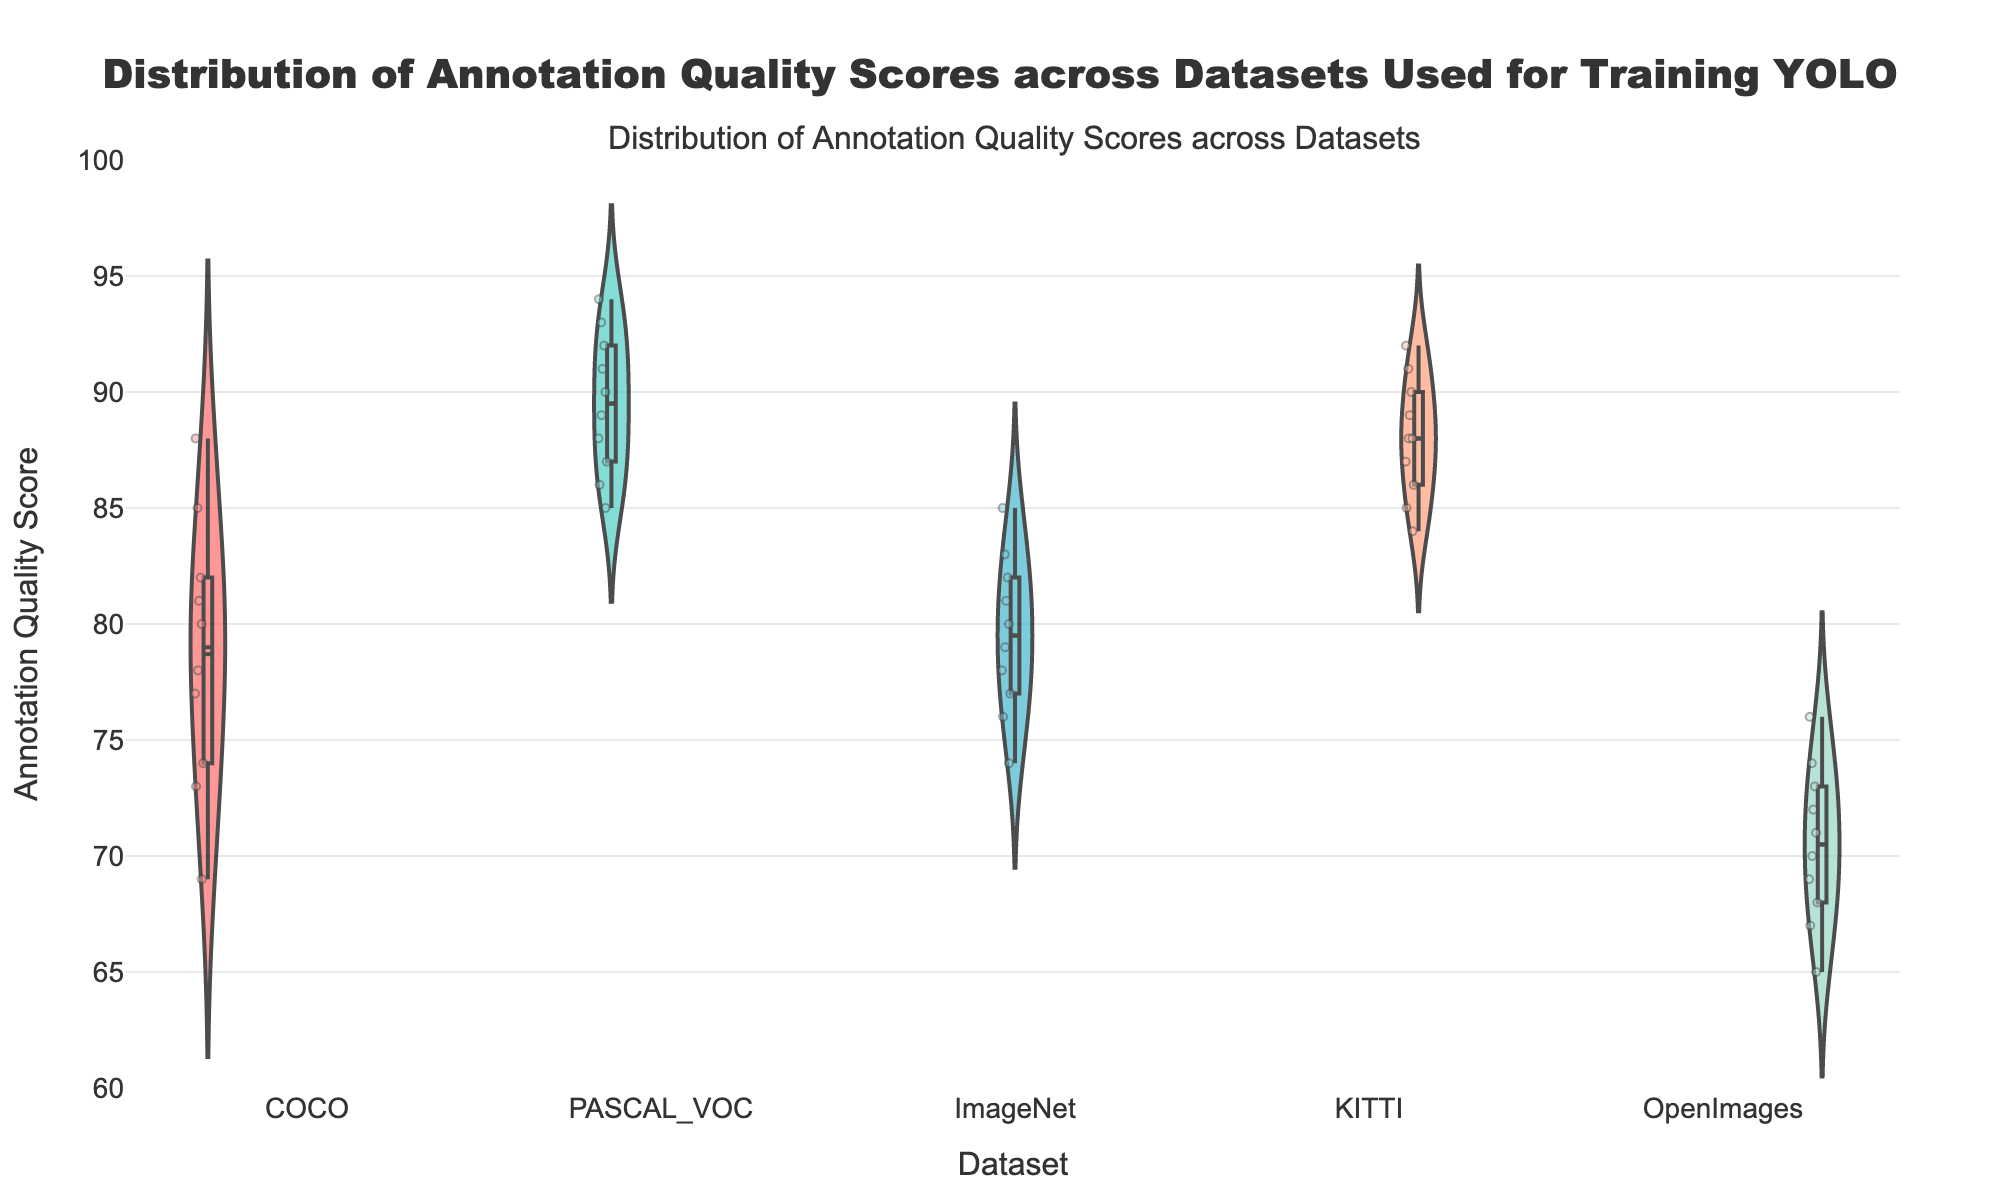What's the title of the subplot? The title of the subplot is mentioned at the top of the figure.
Answer: Distribution of Annotation Quality Scores across Datasets Which dataset has the highest median annotation quality score? The dataset with the highest median score can be identified by looking at the meanline across the violin plots. The dataset with the highest meanline is PASCAL_VOC.
Answer: PASCAL_VOC What is the range of annotation quality scores for the COCO dataset? The range can be determined by looking at the upper and lower extremes of the COCO violin plot. COCO ranges from approximately 69 to 88.
Answer: 69-88 How does the median quality score of KITTI compare to that of ImageNet? Compare the median (indicated by the meanline) of both datasets. KITTI's median is slightly higher than ImageNet's.
Answer: KITTI's median is higher What is the interquartile range (IQR) of the annotation quality scores for OpenImages? To find the IQR, look for the box within the violin plot for OpenImages. The boundaries of this box represent the first and third quartiles. OpenImages IQR is from approximately 68 to 73.
Answer: 68-73 Which dataset shows the widest distribution of annotation quality scores? This can be determined by comparing the width of the violin plots. OpenImages shows the widest distribution.
Answer: OpenImages Which dataset has the least variability in annotation quality scores? The dataset with the narrowest violin plot width shows the least variability. PASCAL_VOC shows the least variability.
Answer: PASCAL_VOC Which dataset has scores below 70? By examining the plots, OpenImages has scores that go below 70.
Answer: OpenImages Are there any outliers or significantly different data points in the ImageNet dataset? Outliers can sometimes be seen as individual data points outside the main bulk of the violin plot. ImageNet does not appear to have significant outliers.
Answer: No What's the most frequent score range for KITTI? The most populated range can be inferred from the density of the violin plot. For KITTI, it appears to be between 84 and 92.
Answer: 84-92 